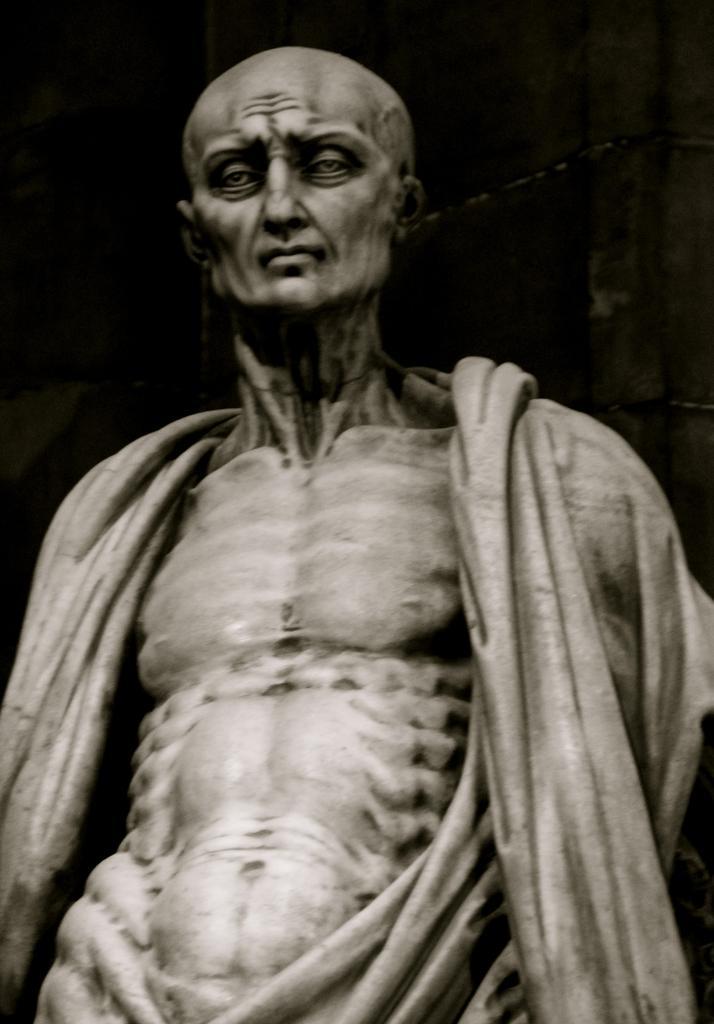Describe this image in one or two sentences. There is a sculpture in the center of the image and the background is dark. 